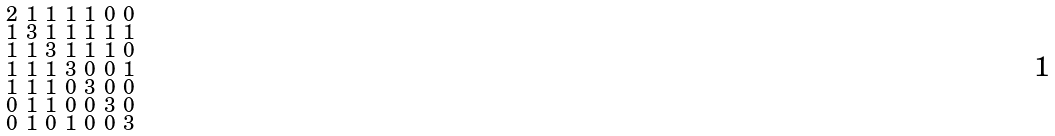<formula> <loc_0><loc_0><loc_500><loc_500>\begin{smallmatrix} 2 & 1 & 1 & 1 & 1 & 0 & 0 \\ 1 & 3 & 1 & 1 & 1 & 1 & 1 \\ 1 & 1 & 3 & 1 & 1 & 1 & 0 \\ 1 & 1 & 1 & 3 & 0 & 0 & 1 \\ 1 & 1 & 1 & 0 & 3 & 0 & 0 \\ 0 & 1 & 1 & 0 & 0 & 3 & 0 \\ 0 & 1 & 0 & 1 & 0 & 0 & 3 \end{smallmatrix}</formula> 